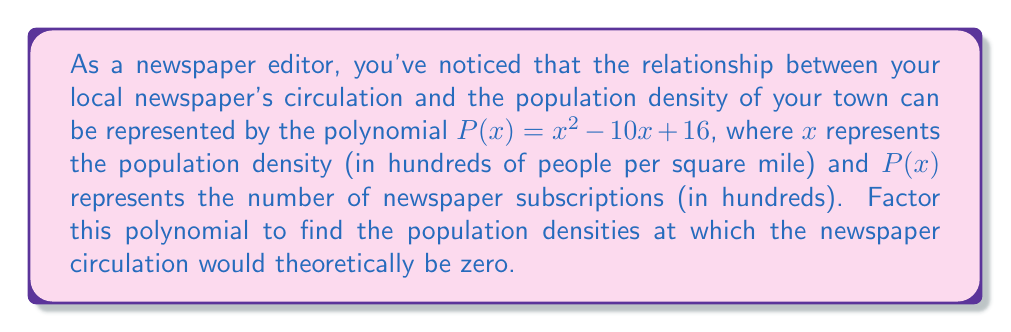Help me with this question. To factor this quadratic polynomial, we'll use the following steps:

1) First, we identify that this is a quadratic polynomial in the form $ax^2 + bx + c$, where:
   $a = 1$
   $b = -10$
   $c = 16$

2) We'll use the factoring method by finding two numbers that multiply to give $ac$ and add to give $b$.

3) $ac = 1 \times 16 = 16$
   We need to find two numbers that multiply to give 16 and add to give -10.
   These numbers are -8 and -2.

4) We can rewrite the middle term using these numbers:
   $P(x) = x^2 - 8x - 2x + 16$

5) Now we can factor by grouping:
   $P(x) = (x^2 - 8x) + (-2x + 16)$
   $P(x) = x(x - 8) - 2(x - 8)$
   $P(x) = (x - 8)(x - 2)$

6) The factored form $(x - 8)(x - 2)$ gives us the roots of the polynomial, which are the values of $x$ where $P(x) = 0$.

7) These roots occur at $x = 8$ and $x = 2$.

Therefore, the newspaper circulation would theoretically be zero when the population density is 200 people per square mile (x = 2) or 800 people per square mile (x = 8).
Answer: $P(x) = (x - 8)(x - 2)$
The roots are $x = 8$ and $x = 2$, corresponding to population densities of 800 and 200 people per square mile, respectively. 